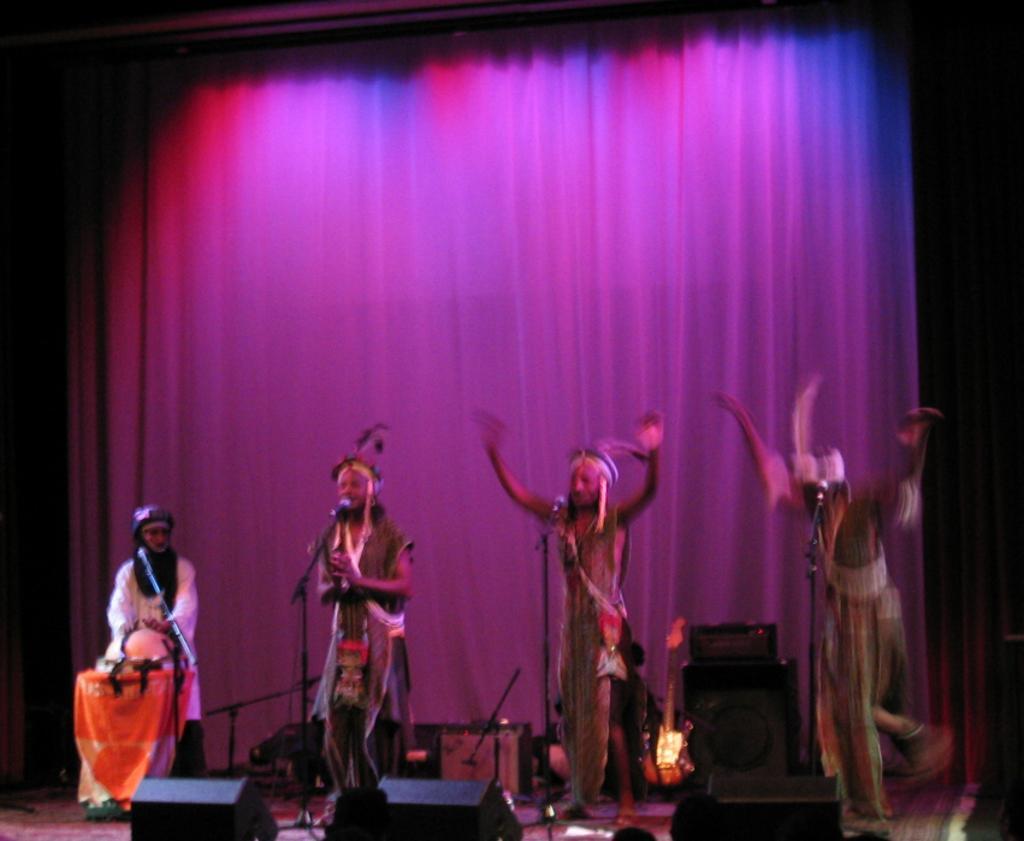In one or two sentences, can you explain what this image depicts? In this image in the front there are objects which are black in colour. In the center there are artists performing on the stage and there are mics. In the background there is an object which is black in colour and there is a curtain. 